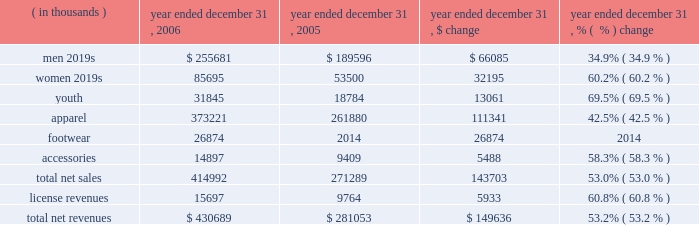Year ended december 31 , 2006 compared to year ended december 31 , 2005 net revenues increased $ 149.6 million , or 53.2% ( 53.2 % ) , to $ 430.7 million in 2006 from $ 281.1 million in 2005 .
This increase was the result of increases in both our net sales and license revenues as noted in the product category table below. .
Net sales increased $ 143.7 million , or 53.0% ( 53.0 % ) , to $ 415.0 million for the year ended december 31 , 2006 from $ 271.3 million during the same period in 2005 as noted in the table above .
The increase in net sales primarily reflects : 2022 $ 26.9 million of footwear product sales , primarily football cleats introduced in the second quarter of 2006 , and baseball cleats introduced in the fourth quarter of 2006 ; 2022 continued unit volume growth of our existing products , such as coldgear ae compression products , primarily sold to existing retail customers due to additional retail stores and expanded floor space ; 2022 growth in the average selling price of apparel products within all categories ; 2022 increased women 2019s and youth market penetration by leveraging current customer relationships ; and 2022 product introductions subsequent to december 31 , 2005 within all product categories , most significantly in our compression and training products .
License revenues increased $ 5.9 million , or 60.8% ( 60.8 % ) , to $ 15.7 million for the year ended december 31 , 2006 from $ 9.8 million during the same period in 2005 .
This increase in license revenues was a result of increased sales by our licensees due to increased distribution , continued unit volume growth , new product offerings and new licensing agreements , which included distribution of products to college bookstores and golf pro shops .
Gross profit increased $ 79.7 million to $ 215.6 million in 2006 from $ 135.9 million in 2005 .
Gross profit as a percentage of net revenues , or gross margin , increased approximately 180 basis points to 50.1% ( 50.1 % ) in 2006 from 48.3% ( 48.3 % ) in 2005 .
This increase in gross margin was primarily driven by the following : 2022 lower product costs as a result of variations in product mix and greater supplier discounts for increased volume and lower cost sourcing arrangements , accounting for an approximate 170 basis point increase ; 2022 decreased close-out sales in the 2006 period compared to the 2005 period , accounting for an approximate 70 basis point increase ; 2022 lower customer incentives as a percentage of net revenues , primarily driven by changes to certain customer agreements which decreased discounts while increasing certain customer marketing expenditures recorded in selling , general and administrative expenses , accounting for an approximate 70 basis point increase; .
In 2006 what was the percent of the total net revenues by product category from men? 
Computations: (255681 / 430689)
Answer: 0.59366. 